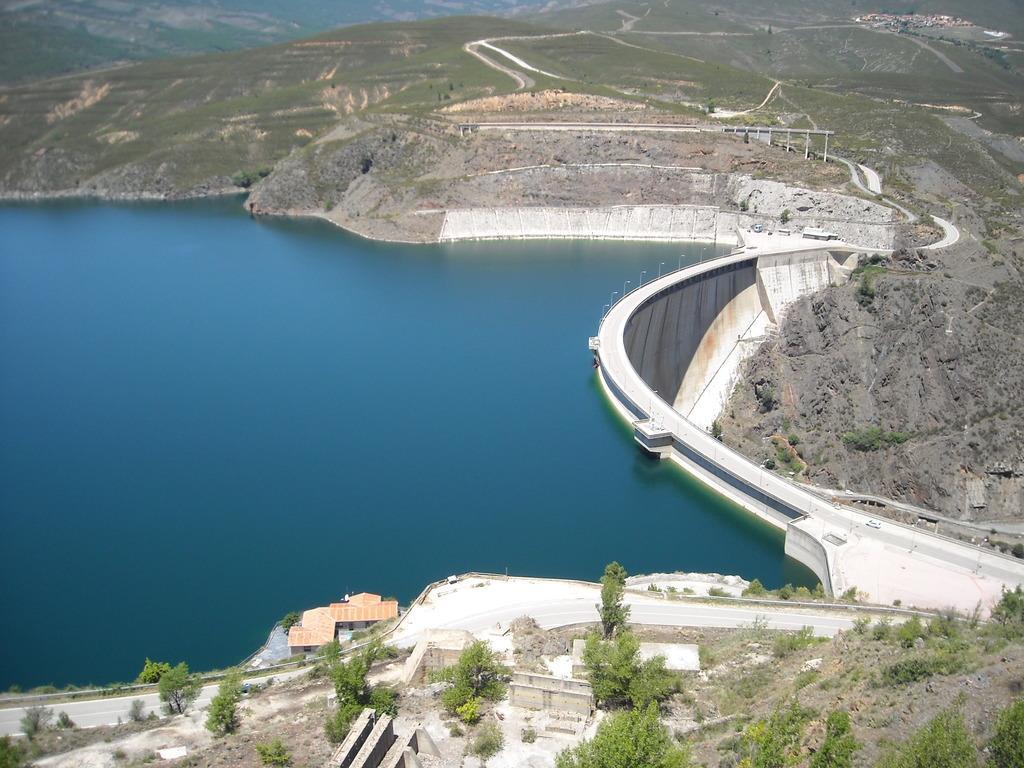Describe this image in one or two sentences. In this image I can see the road. To the side of the road I can see many trees, house, mountains and the water. I can see the water in blue color. 